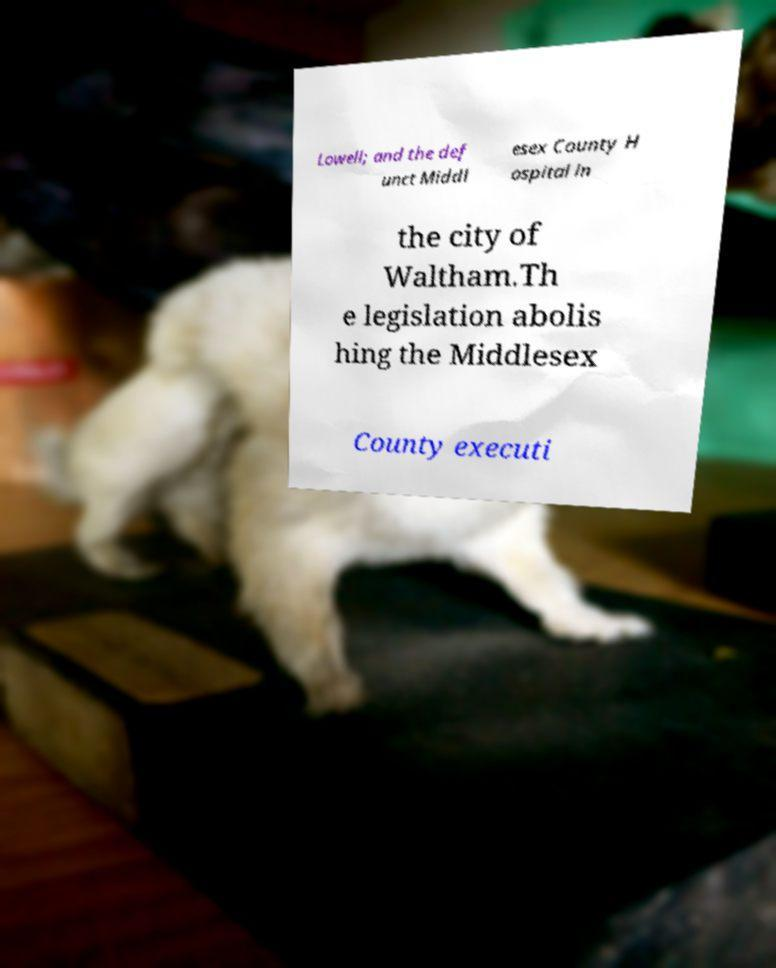What messages or text are displayed in this image? I need them in a readable, typed format. Lowell; and the def unct Middl esex County H ospital in the city of Waltham.Th e legislation abolis hing the Middlesex County executi 